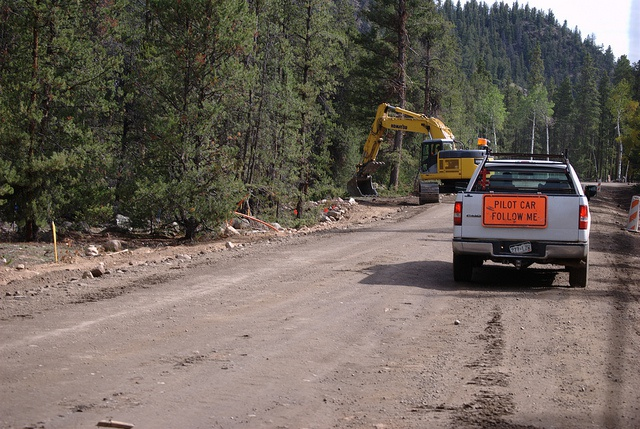Describe the objects in this image and their specific colors. I can see truck in black and gray tones, people in black, navy, purple, and gray tones, and people in black, darkblue, gray, and purple tones in this image. 